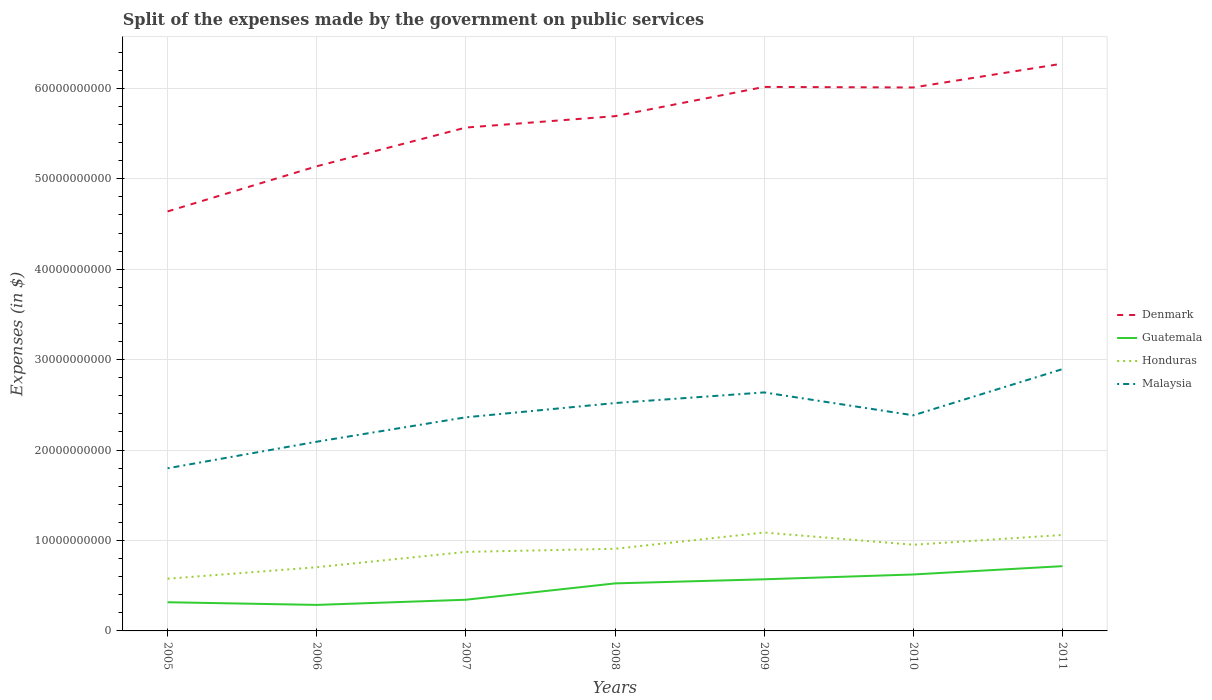How many different coloured lines are there?
Offer a terse response. 4. Is the number of lines equal to the number of legend labels?
Make the answer very short. Yes. Across all years, what is the maximum expenses made by the government on public services in Denmark?
Keep it short and to the point. 4.64e+1. In which year was the expenses made by the government on public services in Guatemala maximum?
Offer a very short reply. 2006. What is the total expenses made by the government on public services in Guatemala in the graph?
Make the answer very short. -3.99e+09. What is the difference between the highest and the second highest expenses made by the government on public services in Malaysia?
Give a very brief answer. 1.10e+1. Is the expenses made by the government on public services in Denmark strictly greater than the expenses made by the government on public services in Malaysia over the years?
Make the answer very short. No. How many lines are there?
Provide a succinct answer. 4. How many years are there in the graph?
Make the answer very short. 7. Where does the legend appear in the graph?
Make the answer very short. Center right. How many legend labels are there?
Your response must be concise. 4. How are the legend labels stacked?
Give a very brief answer. Vertical. What is the title of the graph?
Make the answer very short. Split of the expenses made by the government on public services. What is the label or title of the Y-axis?
Provide a succinct answer. Expenses (in $). What is the Expenses (in $) of Denmark in 2005?
Ensure brevity in your answer.  4.64e+1. What is the Expenses (in $) of Guatemala in 2005?
Keep it short and to the point. 3.17e+09. What is the Expenses (in $) of Honduras in 2005?
Your answer should be compact. 5.77e+09. What is the Expenses (in $) in Malaysia in 2005?
Give a very brief answer. 1.80e+1. What is the Expenses (in $) of Denmark in 2006?
Your answer should be compact. 5.14e+1. What is the Expenses (in $) of Guatemala in 2006?
Provide a short and direct response. 2.88e+09. What is the Expenses (in $) of Honduras in 2006?
Your response must be concise. 7.04e+09. What is the Expenses (in $) in Malaysia in 2006?
Keep it short and to the point. 2.09e+1. What is the Expenses (in $) of Denmark in 2007?
Offer a terse response. 5.57e+1. What is the Expenses (in $) of Guatemala in 2007?
Keep it short and to the point. 3.45e+09. What is the Expenses (in $) in Honduras in 2007?
Offer a very short reply. 8.74e+09. What is the Expenses (in $) in Malaysia in 2007?
Offer a very short reply. 2.36e+1. What is the Expenses (in $) of Denmark in 2008?
Your answer should be compact. 5.69e+1. What is the Expenses (in $) of Guatemala in 2008?
Provide a short and direct response. 5.26e+09. What is the Expenses (in $) in Honduras in 2008?
Give a very brief answer. 9.08e+09. What is the Expenses (in $) of Malaysia in 2008?
Offer a very short reply. 2.52e+1. What is the Expenses (in $) in Denmark in 2009?
Your answer should be compact. 6.02e+1. What is the Expenses (in $) of Guatemala in 2009?
Provide a succinct answer. 5.71e+09. What is the Expenses (in $) of Honduras in 2009?
Offer a terse response. 1.09e+1. What is the Expenses (in $) in Malaysia in 2009?
Your answer should be very brief. 2.64e+1. What is the Expenses (in $) of Denmark in 2010?
Your answer should be compact. 6.01e+1. What is the Expenses (in $) of Guatemala in 2010?
Make the answer very short. 6.24e+09. What is the Expenses (in $) of Honduras in 2010?
Offer a terse response. 9.53e+09. What is the Expenses (in $) in Malaysia in 2010?
Your answer should be compact. 2.38e+1. What is the Expenses (in $) in Denmark in 2011?
Offer a very short reply. 6.27e+1. What is the Expenses (in $) in Guatemala in 2011?
Your answer should be very brief. 7.16e+09. What is the Expenses (in $) of Honduras in 2011?
Your answer should be very brief. 1.06e+1. What is the Expenses (in $) of Malaysia in 2011?
Offer a very short reply. 2.89e+1. Across all years, what is the maximum Expenses (in $) of Denmark?
Keep it short and to the point. 6.27e+1. Across all years, what is the maximum Expenses (in $) in Guatemala?
Your answer should be compact. 7.16e+09. Across all years, what is the maximum Expenses (in $) of Honduras?
Provide a short and direct response. 1.09e+1. Across all years, what is the maximum Expenses (in $) of Malaysia?
Provide a short and direct response. 2.89e+1. Across all years, what is the minimum Expenses (in $) in Denmark?
Keep it short and to the point. 4.64e+1. Across all years, what is the minimum Expenses (in $) of Guatemala?
Your answer should be compact. 2.88e+09. Across all years, what is the minimum Expenses (in $) of Honduras?
Your response must be concise. 5.77e+09. Across all years, what is the minimum Expenses (in $) in Malaysia?
Provide a short and direct response. 1.80e+1. What is the total Expenses (in $) of Denmark in the graph?
Offer a very short reply. 3.93e+11. What is the total Expenses (in $) in Guatemala in the graph?
Offer a terse response. 3.39e+1. What is the total Expenses (in $) in Honduras in the graph?
Make the answer very short. 6.17e+1. What is the total Expenses (in $) in Malaysia in the graph?
Your answer should be compact. 1.67e+11. What is the difference between the Expenses (in $) of Denmark in 2005 and that in 2006?
Offer a terse response. -4.99e+09. What is the difference between the Expenses (in $) in Guatemala in 2005 and that in 2006?
Your answer should be compact. 2.95e+08. What is the difference between the Expenses (in $) in Honduras in 2005 and that in 2006?
Give a very brief answer. -1.27e+09. What is the difference between the Expenses (in $) in Malaysia in 2005 and that in 2006?
Offer a very short reply. -2.94e+09. What is the difference between the Expenses (in $) in Denmark in 2005 and that in 2007?
Your answer should be compact. -9.27e+09. What is the difference between the Expenses (in $) in Guatemala in 2005 and that in 2007?
Your response must be concise. -2.76e+08. What is the difference between the Expenses (in $) of Honduras in 2005 and that in 2007?
Your answer should be very brief. -2.97e+09. What is the difference between the Expenses (in $) of Malaysia in 2005 and that in 2007?
Make the answer very short. -5.64e+09. What is the difference between the Expenses (in $) in Denmark in 2005 and that in 2008?
Make the answer very short. -1.05e+1. What is the difference between the Expenses (in $) of Guatemala in 2005 and that in 2008?
Provide a succinct answer. -2.08e+09. What is the difference between the Expenses (in $) of Honduras in 2005 and that in 2008?
Make the answer very short. -3.31e+09. What is the difference between the Expenses (in $) of Malaysia in 2005 and that in 2008?
Give a very brief answer. -7.21e+09. What is the difference between the Expenses (in $) in Denmark in 2005 and that in 2009?
Keep it short and to the point. -1.38e+1. What is the difference between the Expenses (in $) in Guatemala in 2005 and that in 2009?
Keep it short and to the point. -2.54e+09. What is the difference between the Expenses (in $) of Honduras in 2005 and that in 2009?
Provide a short and direct response. -5.11e+09. What is the difference between the Expenses (in $) of Malaysia in 2005 and that in 2009?
Give a very brief answer. -8.39e+09. What is the difference between the Expenses (in $) in Denmark in 2005 and that in 2010?
Provide a succinct answer. -1.37e+1. What is the difference between the Expenses (in $) of Guatemala in 2005 and that in 2010?
Offer a terse response. -3.07e+09. What is the difference between the Expenses (in $) in Honduras in 2005 and that in 2010?
Your response must be concise. -3.76e+09. What is the difference between the Expenses (in $) in Malaysia in 2005 and that in 2010?
Your answer should be very brief. -5.86e+09. What is the difference between the Expenses (in $) of Denmark in 2005 and that in 2011?
Your answer should be compact. -1.63e+1. What is the difference between the Expenses (in $) of Guatemala in 2005 and that in 2011?
Make the answer very short. -3.99e+09. What is the difference between the Expenses (in $) of Honduras in 2005 and that in 2011?
Make the answer very short. -4.84e+09. What is the difference between the Expenses (in $) in Malaysia in 2005 and that in 2011?
Offer a terse response. -1.10e+1. What is the difference between the Expenses (in $) of Denmark in 2006 and that in 2007?
Your response must be concise. -4.28e+09. What is the difference between the Expenses (in $) in Guatemala in 2006 and that in 2007?
Your answer should be very brief. -5.70e+08. What is the difference between the Expenses (in $) in Honduras in 2006 and that in 2007?
Ensure brevity in your answer.  -1.70e+09. What is the difference between the Expenses (in $) in Malaysia in 2006 and that in 2007?
Your response must be concise. -2.70e+09. What is the difference between the Expenses (in $) in Denmark in 2006 and that in 2008?
Provide a short and direct response. -5.54e+09. What is the difference between the Expenses (in $) of Guatemala in 2006 and that in 2008?
Offer a very short reply. -2.38e+09. What is the difference between the Expenses (in $) in Honduras in 2006 and that in 2008?
Your response must be concise. -2.04e+09. What is the difference between the Expenses (in $) in Malaysia in 2006 and that in 2008?
Your answer should be very brief. -4.27e+09. What is the difference between the Expenses (in $) in Denmark in 2006 and that in 2009?
Your answer should be very brief. -8.77e+09. What is the difference between the Expenses (in $) of Guatemala in 2006 and that in 2009?
Your answer should be very brief. -2.83e+09. What is the difference between the Expenses (in $) in Honduras in 2006 and that in 2009?
Provide a short and direct response. -3.84e+09. What is the difference between the Expenses (in $) of Malaysia in 2006 and that in 2009?
Provide a succinct answer. -5.45e+09. What is the difference between the Expenses (in $) in Denmark in 2006 and that in 2010?
Your answer should be very brief. -8.71e+09. What is the difference between the Expenses (in $) of Guatemala in 2006 and that in 2010?
Provide a succinct answer. -3.36e+09. What is the difference between the Expenses (in $) of Honduras in 2006 and that in 2010?
Your answer should be compact. -2.49e+09. What is the difference between the Expenses (in $) of Malaysia in 2006 and that in 2010?
Your answer should be very brief. -2.92e+09. What is the difference between the Expenses (in $) in Denmark in 2006 and that in 2011?
Your response must be concise. -1.13e+1. What is the difference between the Expenses (in $) of Guatemala in 2006 and that in 2011?
Your answer should be compact. -4.28e+09. What is the difference between the Expenses (in $) in Honduras in 2006 and that in 2011?
Ensure brevity in your answer.  -3.56e+09. What is the difference between the Expenses (in $) of Malaysia in 2006 and that in 2011?
Offer a terse response. -8.03e+09. What is the difference between the Expenses (in $) in Denmark in 2007 and that in 2008?
Your answer should be very brief. -1.26e+09. What is the difference between the Expenses (in $) in Guatemala in 2007 and that in 2008?
Keep it short and to the point. -1.81e+09. What is the difference between the Expenses (in $) of Honduras in 2007 and that in 2008?
Your answer should be compact. -3.42e+08. What is the difference between the Expenses (in $) of Malaysia in 2007 and that in 2008?
Give a very brief answer. -1.57e+09. What is the difference between the Expenses (in $) of Denmark in 2007 and that in 2009?
Your response must be concise. -4.49e+09. What is the difference between the Expenses (in $) in Guatemala in 2007 and that in 2009?
Make the answer very short. -2.26e+09. What is the difference between the Expenses (in $) of Honduras in 2007 and that in 2009?
Offer a very short reply. -2.14e+09. What is the difference between the Expenses (in $) of Malaysia in 2007 and that in 2009?
Ensure brevity in your answer.  -2.75e+09. What is the difference between the Expenses (in $) in Denmark in 2007 and that in 2010?
Offer a terse response. -4.43e+09. What is the difference between the Expenses (in $) in Guatemala in 2007 and that in 2010?
Your answer should be very brief. -2.79e+09. What is the difference between the Expenses (in $) of Honduras in 2007 and that in 2010?
Your answer should be compact. -7.91e+08. What is the difference between the Expenses (in $) of Malaysia in 2007 and that in 2010?
Ensure brevity in your answer.  -2.18e+08. What is the difference between the Expenses (in $) in Denmark in 2007 and that in 2011?
Your response must be concise. -7.07e+09. What is the difference between the Expenses (in $) of Guatemala in 2007 and that in 2011?
Make the answer very short. -3.71e+09. What is the difference between the Expenses (in $) of Honduras in 2007 and that in 2011?
Your answer should be compact. -1.87e+09. What is the difference between the Expenses (in $) in Malaysia in 2007 and that in 2011?
Your response must be concise. -5.33e+09. What is the difference between the Expenses (in $) of Denmark in 2008 and that in 2009?
Keep it short and to the point. -3.23e+09. What is the difference between the Expenses (in $) of Guatemala in 2008 and that in 2009?
Make the answer very short. -4.52e+08. What is the difference between the Expenses (in $) in Honduras in 2008 and that in 2009?
Provide a succinct answer. -1.80e+09. What is the difference between the Expenses (in $) in Malaysia in 2008 and that in 2009?
Give a very brief answer. -1.18e+09. What is the difference between the Expenses (in $) in Denmark in 2008 and that in 2010?
Offer a terse response. -3.17e+09. What is the difference between the Expenses (in $) of Guatemala in 2008 and that in 2010?
Your answer should be very brief. -9.86e+08. What is the difference between the Expenses (in $) in Honduras in 2008 and that in 2010?
Your answer should be very brief. -4.48e+08. What is the difference between the Expenses (in $) of Malaysia in 2008 and that in 2010?
Provide a succinct answer. 1.36e+09. What is the difference between the Expenses (in $) of Denmark in 2008 and that in 2011?
Give a very brief answer. -5.81e+09. What is the difference between the Expenses (in $) of Guatemala in 2008 and that in 2011?
Offer a very short reply. -1.91e+09. What is the difference between the Expenses (in $) of Honduras in 2008 and that in 2011?
Offer a very short reply. -1.53e+09. What is the difference between the Expenses (in $) of Malaysia in 2008 and that in 2011?
Your answer should be compact. -3.75e+09. What is the difference between the Expenses (in $) of Denmark in 2009 and that in 2010?
Ensure brevity in your answer.  6.10e+07. What is the difference between the Expenses (in $) of Guatemala in 2009 and that in 2010?
Ensure brevity in your answer.  -5.34e+08. What is the difference between the Expenses (in $) of Honduras in 2009 and that in 2010?
Your answer should be compact. 1.35e+09. What is the difference between the Expenses (in $) of Malaysia in 2009 and that in 2010?
Your response must be concise. 2.53e+09. What is the difference between the Expenses (in $) of Denmark in 2009 and that in 2011?
Give a very brief answer. -2.58e+09. What is the difference between the Expenses (in $) in Guatemala in 2009 and that in 2011?
Keep it short and to the point. -1.45e+09. What is the difference between the Expenses (in $) of Honduras in 2009 and that in 2011?
Ensure brevity in your answer.  2.73e+08. What is the difference between the Expenses (in $) of Malaysia in 2009 and that in 2011?
Your answer should be very brief. -2.58e+09. What is the difference between the Expenses (in $) in Denmark in 2010 and that in 2011?
Offer a terse response. -2.64e+09. What is the difference between the Expenses (in $) of Guatemala in 2010 and that in 2011?
Your answer should be very brief. -9.19e+08. What is the difference between the Expenses (in $) in Honduras in 2010 and that in 2011?
Your answer should be very brief. -1.08e+09. What is the difference between the Expenses (in $) in Malaysia in 2010 and that in 2011?
Keep it short and to the point. -5.11e+09. What is the difference between the Expenses (in $) of Denmark in 2005 and the Expenses (in $) of Guatemala in 2006?
Give a very brief answer. 4.35e+1. What is the difference between the Expenses (in $) of Denmark in 2005 and the Expenses (in $) of Honduras in 2006?
Provide a short and direct response. 3.93e+1. What is the difference between the Expenses (in $) of Denmark in 2005 and the Expenses (in $) of Malaysia in 2006?
Your answer should be compact. 2.55e+1. What is the difference between the Expenses (in $) of Guatemala in 2005 and the Expenses (in $) of Honduras in 2006?
Provide a short and direct response. -3.87e+09. What is the difference between the Expenses (in $) in Guatemala in 2005 and the Expenses (in $) in Malaysia in 2006?
Your response must be concise. -1.78e+1. What is the difference between the Expenses (in $) in Honduras in 2005 and the Expenses (in $) in Malaysia in 2006?
Provide a short and direct response. -1.52e+1. What is the difference between the Expenses (in $) of Denmark in 2005 and the Expenses (in $) of Guatemala in 2007?
Make the answer very short. 4.29e+1. What is the difference between the Expenses (in $) in Denmark in 2005 and the Expenses (in $) in Honduras in 2007?
Provide a short and direct response. 3.76e+1. What is the difference between the Expenses (in $) in Denmark in 2005 and the Expenses (in $) in Malaysia in 2007?
Offer a very short reply. 2.28e+1. What is the difference between the Expenses (in $) of Guatemala in 2005 and the Expenses (in $) of Honduras in 2007?
Provide a short and direct response. -5.57e+09. What is the difference between the Expenses (in $) in Guatemala in 2005 and the Expenses (in $) in Malaysia in 2007?
Give a very brief answer. -2.05e+1. What is the difference between the Expenses (in $) in Honduras in 2005 and the Expenses (in $) in Malaysia in 2007?
Your answer should be very brief. -1.79e+1. What is the difference between the Expenses (in $) of Denmark in 2005 and the Expenses (in $) of Guatemala in 2008?
Give a very brief answer. 4.11e+1. What is the difference between the Expenses (in $) in Denmark in 2005 and the Expenses (in $) in Honduras in 2008?
Offer a terse response. 3.73e+1. What is the difference between the Expenses (in $) in Denmark in 2005 and the Expenses (in $) in Malaysia in 2008?
Your answer should be compact. 2.12e+1. What is the difference between the Expenses (in $) in Guatemala in 2005 and the Expenses (in $) in Honduras in 2008?
Your response must be concise. -5.91e+09. What is the difference between the Expenses (in $) in Guatemala in 2005 and the Expenses (in $) in Malaysia in 2008?
Offer a terse response. -2.20e+1. What is the difference between the Expenses (in $) of Honduras in 2005 and the Expenses (in $) of Malaysia in 2008?
Give a very brief answer. -1.94e+1. What is the difference between the Expenses (in $) of Denmark in 2005 and the Expenses (in $) of Guatemala in 2009?
Give a very brief answer. 4.07e+1. What is the difference between the Expenses (in $) of Denmark in 2005 and the Expenses (in $) of Honduras in 2009?
Offer a terse response. 3.55e+1. What is the difference between the Expenses (in $) in Denmark in 2005 and the Expenses (in $) in Malaysia in 2009?
Your response must be concise. 2.00e+1. What is the difference between the Expenses (in $) in Guatemala in 2005 and the Expenses (in $) in Honduras in 2009?
Offer a very short reply. -7.71e+09. What is the difference between the Expenses (in $) in Guatemala in 2005 and the Expenses (in $) in Malaysia in 2009?
Keep it short and to the point. -2.32e+1. What is the difference between the Expenses (in $) of Honduras in 2005 and the Expenses (in $) of Malaysia in 2009?
Offer a very short reply. -2.06e+1. What is the difference between the Expenses (in $) in Denmark in 2005 and the Expenses (in $) in Guatemala in 2010?
Give a very brief answer. 4.01e+1. What is the difference between the Expenses (in $) in Denmark in 2005 and the Expenses (in $) in Honduras in 2010?
Provide a short and direct response. 3.69e+1. What is the difference between the Expenses (in $) of Denmark in 2005 and the Expenses (in $) of Malaysia in 2010?
Offer a very short reply. 2.25e+1. What is the difference between the Expenses (in $) in Guatemala in 2005 and the Expenses (in $) in Honduras in 2010?
Keep it short and to the point. -6.36e+09. What is the difference between the Expenses (in $) of Guatemala in 2005 and the Expenses (in $) of Malaysia in 2010?
Make the answer very short. -2.07e+1. What is the difference between the Expenses (in $) in Honduras in 2005 and the Expenses (in $) in Malaysia in 2010?
Keep it short and to the point. -1.81e+1. What is the difference between the Expenses (in $) of Denmark in 2005 and the Expenses (in $) of Guatemala in 2011?
Offer a very short reply. 3.92e+1. What is the difference between the Expenses (in $) of Denmark in 2005 and the Expenses (in $) of Honduras in 2011?
Offer a terse response. 3.58e+1. What is the difference between the Expenses (in $) in Denmark in 2005 and the Expenses (in $) in Malaysia in 2011?
Make the answer very short. 1.74e+1. What is the difference between the Expenses (in $) in Guatemala in 2005 and the Expenses (in $) in Honduras in 2011?
Ensure brevity in your answer.  -7.44e+09. What is the difference between the Expenses (in $) of Guatemala in 2005 and the Expenses (in $) of Malaysia in 2011?
Your answer should be compact. -2.58e+1. What is the difference between the Expenses (in $) of Honduras in 2005 and the Expenses (in $) of Malaysia in 2011?
Your answer should be very brief. -2.32e+1. What is the difference between the Expenses (in $) in Denmark in 2006 and the Expenses (in $) in Guatemala in 2007?
Keep it short and to the point. 4.79e+1. What is the difference between the Expenses (in $) of Denmark in 2006 and the Expenses (in $) of Honduras in 2007?
Give a very brief answer. 4.26e+1. What is the difference between the Expenses (in $) in Denmark in 2006 and the Expenses (in $) in Malaysia in 2007?
Offer a terse response. 2.78e+1. What is the difference between the Expenses (in $) in Guatemala in 2006 and the Expenses (in $) in Honduras in 2007?
Make the answer very short. -5.86e+09. What is the difference between the Expenses (in $) in Guatemala in 2006 and the Expenses (in $) in Malaysia in 2007?
Provide a short and direct response. -2.07e+1. What is the difference between the Expenses (in $) in Honduras in 2006 and the Expenses (in $) in Malaysia in 2007?
Offer a terse response. -1.66e+1. What is the difference between the Expenses (in $) in Denmark in 2006 and the Expenses (in $) in Guatemala in 2008?
Your answer should be very brief. 4.61e+1. What is the difference between the Expenses (in $) of Denmark in 2006 and the Expenses (in $) of Honduras in 2008?
Your answer should be compact. 4.23e+1. What is the difference between the Expenses (in $) in Denmark in 2006 and the Expenses (in $) in Malaysia in 2008?
Provide a succinct answer. 2.62e+1. What is the difference between the Expenses (in $) in Guatemala in 2006 and the Expenses (in $) in Honduras in 2008?
Provide a short and direct response. -6.20e+09. What is the difference between the Expenses (in $) of Guatemala in 2006 and the Expenses (in $) of Malaysia in 2008?
Provide a succinct answer. -2.23e+1. What is the difference between the Expenses (in $) in Honduras in 2006 and the Expenses (in $) in Malaysia in 2008?
Provide a short and direct response. -1.82e+1. What is the difference between the Expenses (in $) in Denmark in 2006 and the Expenses (in $) in Guatemala in 2009?
Offer a terse response. 4.57e+1. What is the difference between the Expenses (in $) in Denmark in 2006 and the Expenses (in $) in Honduras in 2009?
Keep it short and to the point. 4.05e+1. What is the difference between the Expenses (in $) of Denmark in 2006 and the Expenses (in $) of Malaysia in 2009?
Your answer should be very brief. 2.50e+1. What is the difference between the Expenses (in $) in Guatemala in 2006 and the Expenses (in $) in Honduras in 2009?
Your answer should be very brief. -8.00e+09. What is the difference between the Expenses (in $) of Guatemala in 2006 and the Expenses (in $) of Malaysia in 2009?
Make the answer very short. -2.35e+1. What is the difference between the Expenses (in $) in Honduras in 2006 and the Expenses (in $) in Malaysia in 2009?
Make the answer very short. -1.93e+1. What is the difference between the Expenses (in $) of Denmark in 2006 and the Expenses (in $) of Guatemala in 2010?
Your answer should be very brief. 4.51e+1. What is the difference between the Expenses (in $) in Denmark in 2006 and the Expenses (in $) in Honduras in 2010?
Keep it short and to the point. 4.19e+1. What is the difference between the Expenses (in $) of Denmark in 2006 and the Expenses (in $) of Malaysia in 2010?
Keep it short and to the point. 2.75e+1. What is the difference between the Expenses (in $) of Guatemala in 2006 and the Expenses (in $) of Honduras in 2010?
Offer a terse response. -6.65e+09. What is the difference between the Expenses (in $) of Guatemala in 2006 and the Expenses (in $) of Malaysia in 2010?
Your answer should be very brief. -2.10e+1. What is the difference between the Expenses (in $) in Honduras in 2006 and the Expenses (in $) in Malaysia in 2010?
Offer a terse response. -1.68e+1. What is the difference between the Expenses (in $) in Denmark in 2006 and the Expenses (in $) in Guatemala in 2011?
Offer a terse response. 4.42e+1. What is the difference between the Expenses (in $) in Denmark in 2006 and the Expenses (in $) in Honduras in 2011?
Provide a succinct answer. 4.08e+1. What is the difference between the Expenses (in $) of Denmark in 2006 and the Expenses (in $) of Malaysia in 2011?
Give a very brief answer. 2.24e+1. What is the difference between the Expenses (in $) of Guatemala in 2006 and the Expenses (in $) of Honduras in 2011?
Make the answer very short. -7.73e+09. What is the difference between the Expenses (in $) of Guatemala in 2006 and the Expenses (in $) of Malaysia in 2011?
Provide a short and direct response. -2.61e+1. What is the difference between the Expenses (in $) of Honduras in 2006 and the Expenses (in $) of Malaysia in 2011?
Offer a terse response. -2.19e+1. What is the difference between the Expenses (in $) in Denmark in 2007 and the Expenses (in $) in Guatemala in 2008?
Your answer should be very brief. 5.04e+1. What is the difference between the Expenses (in $) of Denmark in 2007 and the Expenses (in $) of Honduras in 2008?
Make the answer very short. 4.66e+1. What is the difference between the Expenses (in $) of Denmark in 2007 and the Expenses (in $) of Malaysia in 2008?
Ensure brevity in your answer.  3.05e+1. What is the difference between the Expenses (in $) of Guatemala in 2007 and the Expenses (in $) of Honduras in 2008?
Provide a short and direct response. -5.63e+09. What is the difference between the Expenses (in $) of Guatemala in 2007 and the Expenses (in $) of Malaysia in 2008?
Keep it short and to the point. -2.17e+1. What is the difference between the Expenses (in $) in Honduras in 2007 and the Expenses (in $) in Malaysia in 2008?
Your answer should be compact. -1.65e+1. What is the difference between the Expenses (in $) of Denmark in 2007 and the Expenses (in $) of Guatemala in 2009?
Your response must be concise. 5.00e+1. What is the difference between the Expenses (in $) of Denmark in 2007 and the Expenses (in $) of Honduras in 2009?
Offer a terse response. 4.48e+1. What is the difference between the Expenses (in $) of Denmark in 2007 and the Expenses (in $) of Malaysia in 2009?
Your answer should be compact. 2.93e+1. What is the difference between the Expenses (in $) of Guatemala in 2007 and the Expenses (in $) of Honduras in 2009?
Provide a succinct answer. -7.43e+09. What is the difference between the Expenses (in $) of Guatemala in 2007 and the Expenses (in $) of Malaysia in 2009?
Offer a terse response. -2.29e+1. What is the difference between the Expenses (in $) of Honduras in 2007 and the Expenses (in $) of Malaysia in 2009?
Provide a succinct answer. -1.76e+1. What is the difference between the Expenses (in $) of Denmark in 2007 and the Expenses (in $) of Guatemala in 2010?
Make the answer very short. 4.94e+1. What is the difference between the Expenses (in $) in Denmark in 2007 and the Expenses (in $) in Honduras in 2010?
Make the answer very short. 4.61e+1. What is the difference between the Expenses (in $) in Denmark in 2007 and the Expenses (in $) in Malaysia in 2010?
Your answer should be very brief. 3.18e+1. What is the difference between the Expenses (in $) in Guatemala in 2007 and the Expenses (in $) in Honduras in 2010?
Provide a succinct answer. -6.08e+09. What is the difference between the Expenses (in $) in Guatemala in 2007 and the Expenses (in $) in Malaysia in 2010?
Your answer should be compact. -2.04e+1. What is the difference between the Expenses (in $) in Honduras in 2007 and the Expenses (in $) in Malaysia in 2010?
Your response must be concise. -1.51e+1. What is the difference between the Expenses (in $) in Denmark in 2007 and the Expenses (in $) in Guatemala in 2011?
Your answer should be compact. 4.85e+1. What is the difference between the Expenses (in $) of Denmark in 2007 and the Expenses (in $) of Honduras in 2011?
Offer a very short reply. 4.51e+1. What is the difference between the Expenses (in $) in Denmark in 2007 and the Expenses (in $) in Malaysia in 2011?
Offer a terse response. 2.67e+1. What is the difference between the Expenses (in $) of Guatemala in 2007 and the Expenses (in $) of Honduras in 2011?
Offer a very short reply. -7.16e+09. What is the difference between the Expenses (in $) of Guatemala in 2007 and the Expenses (in $) of Malaysia in 2011?
Offer a terse response. -2.55e+1. What is the difference between the Expenses (in $) of Honduras in 2007 and the Expenses (in $) of Malaysia in 2011?
Keep it short and to the point. -2.02e+1. What is the difference between the Expenses (in $) of Denmark in 2008 and the Expenses (in $) of Guatemala in 2009?
Provide a short and direct response. 5.12e+1. What is the difference between the Expenses (in $) of Denmark in 2008 and the Expenses (in $) of Honduras in 2009?
Your answer should be compact. 4.60e+1. What is the difference between the Expenses (in $) of Denmark in 2008 and the Expenses (in $) of Malaysia in 2009?
Provide a succinct answer. 3.05e+1. What is the difference between the Expenses (in $) of Guatemala in 2008 and the Expenses (in $) of Honduras in 2009?
Your response must be concise. -5.63e+09. What is the difference between the Expenses (in $) in Guatemala in 2008 and the Expenses (in $) in Malaysia in 2009?
Provide a succinct answer. -2.11e+1. What is the difference between the Expenses (in $) in Honduras in 2008 and the Expenses (in $) in Malaysia in 2009?
Offer a very short reply. -1.73e+1. What is the difference between the Expenses (in $) of Denmark in 2008 and the Expenses (in $) of Guatemala in 2010?
Provide a succinct answer. 5.07e+1. What is the difference between the Expenses (in $) of Denmark in 2008 and the Expenses (in $) of Honduras in 2010?
Keep it short and to the point. 4.74e+1. What is the difference between the Expenses (in $) in Denmark in 2008 and the Expenses (in $) in Malaysia in 2010?
Give a very brief answer. 3.31e+1. What is the difference between the Expenses (in $) of Guatemala in 2008 and the Expenses (in $) of Honduras in 2010?
Give a very brief answer. -4.27e+09. What is the difference between the Expenses (in $) in Guatemala in 2008 and the Expenses (in $) in Malaysia in 2010?
Your answer should be very brief. -1.86e+1. What is the difference between the Expenses (in $) of Honduras in 2008 and the Expenses (in $) of Malaysia in 2010?
Your answer should be compact. -1.48e+1. What is the difference between the Expenses (in $) in Denmark in 2008 and the Expenses (in $) in Guatemala in 2011?
Make the answer very short. 4.98e+1. What is the difference between the Expenses (in $) in Denmark in 2008 and the Expenses (in $) in Honduras in 2011?
Provide a succinct answer. 4.63e+1. What is the difference between the Expenses (in $) of Denmark in 2008 and the Expenses (in $) of Malaysia in 2011?
Offer a very short reply. 2.80e+1. What is the difference between the Expenses (in $) of Guatemala in 2008 and the Expenses (in $) of Honduras in 2011?
Offer a very short reply. -5.35e+09. What is the difference between the Expenses (in $) in Guatemala in 2008 and the Expenses (in $) in Malaysia in 2011?
Offer a very short reply. -2.37e+1. What is the difference between the Expenses (in $) of Honduras in 2008 and the Expenses (in $) of Malaysia in 2011?
Offer a terse response. -1.99e+1. What is the difference between the Expenses (in $) of Denmark in 2009 and the Expenses (in $) of Guatemala in 2010?
Provide a short and direct response. 5.39e+1. What is the difference between the Expenses (in $) in Denmark in 2009 and the Expenses (in $) in Honduras in 2010?
Provide a short and direct response. 5.06e+1. What is the difference between the Expenses (in $) in Denmark in 2009 and the Expenses (in $) in Malaysia in 2010?
Your answer should be very brief. 3.63e+1. What is the difference between the Expenses (in $) of Guatemala in 2009 and the Expenses (in $) of Honduras in 2010?
Provide a succinct answer. -3.82e+09. What is the difference between the Expenses (in $) of Guatemala in 2009 and the Expenses (in $) of Malaysia in 2010?
Your answer should be very brief. -1.81e+1. What is the difference between the Expenses (in $) in Honduras in 2009 and the Expenses (in $) in Malaysia in 2010?
Give a very brief answer. -1.30e+1. What is the difference between the Expenses (in $) of Denmark in 2009 and the Expenses (in $) of Guatemala in 2011?
Your response must be concise. 5.30e+1. What is the difference between the Expenses (in $) in Denmark in 2009 and the Expenses (in $) in Honduras in 2011?
Provide a succinct answer. 4.95e+1. What is the difference between the Expenses (in $) in Denmark in 2009 and the Expenses (in $) in Malaysia in 2011?
Keep it short and to the point. 3.12e+1. What is the difference between the Expenses (in $) in Guatemala in 2009 and the Expenses (in $) in Honduras in 2011?
Give a very brief answer. -4.90e+09. What is the difference between the Expenses (in $) of Guatemala in 2009 and the Expenses (in $) of Malaysia in 2011?
Offer a terse response. -2.32e+1. What is the difference between the Expenses (in $) in Honduras in 2009 and the Expenses (in $) in Malaysia in 2011?
Ensure brevity in your answer.  -1.81e+1. What is the difference between the Expenses (in $) in Denmark in 2010 and the Expenses (in $) in Guatemala in 2011?
Keep it short and to the point. 5.29e+1. What is the difference between the Expenses (in $) in Denmark in 2010 and the Expenses (in $) in Honduras in 2011?
Your answer should be compact. 4.95e+1. What is the difference between the Expenses (in $) in Denmark in 2010 and the Expenses (in $) in Malaysia in 2011?
Your answer should be very brief. 3.11e+1. What is the difference between the Expenses (in $) in Guatemala in 2010 and the Expenses (in $) in Honduras in 2011?
Your response must be concise. -4.37e+09. What is the difference between the Expenses (in $) in Guatemala in 2010 and the Expenses (in $) in Malaysia in 2011?
Keep it short and to the point. -2.27e+1. What is the difference between the Expenses (in $) in Honduras in 2010 and the Expenses (in $) in Malaysia in 2011?
Give a very brief answer. -1.94e+1. What is the average Expenses (in $) in Denmark per year?
Your answer should be compact. 5.62e+1. What is the average Expenses (in $) in Guatemala per year?
Offer a very short reply. 4.84e+09. What is the average Expenses (in $) of Honduras per year?
Provide a succinct answer. 8.81e+09. What is the average Expenses (in $) in Malaysia per year?
Your answer should be compact. 2.38e+1. In the year 2005, what is the difference between the Expenses (in $) of Denmark and Expenses (in $) of Guatemala?
Ensure brevity in your answer.  4.32e+1. In the year 2005, what is the difference between the Expenses (in $) in Denmark and Expenses (in $) in Honduras?
Make the answer very short. 4.06e+1. In the year 2005, what is the difference between the Expenses (in $) of Denmark and Expenses (in $) of Malaysia?
Your answer should be compact. 2.84e+1. In the year 2005, what is the difference between the Expenses (in $) of Guatemala and Expenses (in $) of Honduras?
Offer a terse response. -2.60e+09. In the year 2005, what is the difference between the Expenses (in $) of Guatemala and Expenses (in $) of Malaysia?
Keep it short and to the point. -1.48e+1. In the year 2005, what is the difference between the Expenses (in $) of Honduras and Expenses (in $) of Malaysia?
Keep it short and to the point. -1.22e+1. In the year 2006, what is the difference between the Expenses (in $) in Denmark and Expenses (in $) in Guatemala?
Your answer should be very brief. 4.85e+1. In the year 2006, what is the difference between the Expenses (in $) in Denmark and Expenses (in $) in Honduras?
Your answer should be compact. 4.43e+1. In the year 2006, what is the difference between the Expenses (in $) in Denmark and Expenses (in $) in Malaysia?
Ensure brevity in your answer.  3.05e+1. In the year 2006, what is the difference between the Expenses (in $) of Guatemala and Expenses (in $) of Honduras?
Offer a very short reply. -4.17e+09. In the year 2006, what is the difference between the Expenses (in $) in Guatemala and Expenses (in $) in Malaysia?
Provide a short and direct response. -1.80e+1. In the year 2006, what is the difference between the Expenses (in $) in Honduras and Expenses (in $) in Malaysia?
Give a very brief answer. -1.39e+1. In the year 2007, what is the difference between the Expenses (in $) of Denmark and Expenses (in $) of Guatemala?
Provide a short and direct response. 5.22e+1. In the year 2007, what is the difference between the Expenses (in $) of Denmark and Expenses (in $) of Honduras?
Provide a succinct answer. 4.69e+1. In the year 2007, what is the difference between the Expenses (in $) in Denmark and Expenses (in $) in Malaysia?
Your answer should be very brief. 3.20e+1. In the year 2007, what is the difference between the Expenses (in $) of Guatemala and Expenses (in $) of Honduras?
Offer a very short reply. -5.29e+09. In the year 2007, what is the difference between the Expenses (in $) in Guatemala and Expenses (in $) in Malaysia?
Offer a very short reply. -2.02e+1. In the year 2007, what is the difference between the Expenses (in $) in Honduras and Expenses (in $) in Malaysia?
Your answer should be very brief. -1.49e+1. In the year 2008, what is the difference between the Expenses (in $) of Denmark and Expenses (in $) of Guatemala?
Your answer should be compact. 5.17e+1. In the year 2008, what is the difference between the Expenses (in $) in Denmark and Expenses (in $) in Honduras?
Ensure brevity in your answer.  4.78e+1. In the year 2008, what is the difference between the Expenses (in $) of Denmark and Expenses (in $) of Malaysia?
Provide a succinct answer. 3.17e+1. In the year 2008, what is the difference between the Expenses (in $) in Guatemala and Expenses (in $) in Honduras?
Your answer should be compact. -3.83e+09. In the year 2008, what is the difference between the Expenses (in $) in Guatemala and Expenses (in $) in Malaysia?
Provide a succinct answer. -1.99e+1. In the year 2008, what is the difference between the Expenses (in $) of Honduras and Expenses (in $) of Malaysia?
Give a very brief answer. -1.61e+1. In the year 2009, what is the difference between the Expenses (in $) of Denmark and Expenses (in $) of Guatemala?
Ensure brevity in your answer.  5.44e+1. In the year 2009, what is the difference between the Expenses (in $) in Denmark and Expenses (in $) in Honduras?
Your answer should be very brief. 4.93e+1. In the year 2009, what is the difference between the Expenses (in $) of Denmark and Expenses (in $) of Malaysia?
Keep it short and to the point. 3.38e+1. In the year 2009, what is the difference between the Expenses (in $) of Guatemala and Expenses (in $) of Honduras?
Offer a very short reply. -5.17e+09. In the year 2009, what is the difference between the Expenses (in $) of Guatemala and Expenses (in $) of Malaysia?
Your response must be concise. -2.07e+1. In the year 2009, what is the difference between the Expenses (in $) in Honduras and Expenses (in $) in Malaysia?
Make the answer very short. -1.55e+1. In the year 2010, what is the difference between the Expenses (in $) in Denmark and Expenses (in $) in Guatemala?
Provide a short and direct response. 5.39e+1. In the year 2010, what is the difference between the Expenses (in $) in Denmark and Expenses (in $) in Honduras?
Provide a succinct answer. 5.06e+1. In the year 2010, what is the difference between the Expenses (in $) of Denmark and Expenses (in $) of Malaysia?
Offer a terse response. 3.63e+1. In the year 2010, what is the difference between the Expenses (in $) in Guatemala and Expenses (in $) in Honduras?
Your answer should be very brief. -3.29e+09. In the year 2010, what is the difference between the Expenses (in $) of Guatemala and Expenses (in $) of Malaysia?
Provide a short and direct response. -1.76e+1. In the year 2010, what is the difference between the Expenses (in $) in Honduras and Expenses (in $) in Malaysia?
Give a very brief answer. -1.43e+1. In the year 2011, what is the difference between the Expenses (in $) of Denmark and Expenses (in $) of Guatemala?
Provide a short and direct response. 5.56e+1. In the year 2011, what is the difference between the Expenses (in $) in Denmark and Expenses (in $) in Honduras?
Make the answer very short. 5.21e+1. In the year 2011, what is the difference between the Expenses (in $) in Denmark and Expenses (in $) in Malaysia?
Provide a short and direct response. 3.38e+1. In the year 2011, what is the difference between the Expenses (in $) of Guatemala and Expenses (in $) of Honduras?
Provide a succinct answer. -3.45e+09. In the year 2011, what is the difference between the Expenses (in $) of Guatemala and Expenses (in $) of Malaysia?
Your answer should be very brief. -2.18e+1. In the year 2011, what is the difference between the Expenses (in $) in Honduras and Expenses (in $) in Malaysia?
Give a very brief answer. -1.83e+1. What is the ratio of the Expenses (in $) of Denmark in 2005 to that in 2006?
Ensure brevity in your answer.  0.9. What is the ratio of the Expenses (in $) of Guatemala in 2005 to that in 2006?
Ensure brevity in your answer.  1.1. What is the ratio of the Expenses (in $) of Honduras in 2005 to that in 2006?
Your answer should be very brief. 0.82. What is the ratio of the Expenses (in $) in Malaysia in 2005 to that in 2006?
Your response must be concise. 0.86. What is the ratio of the Expenses (in $) in Denmark in 2005 to that in 2007?
Your answer should be very brief. 0.83. What is the ratio of the Expenses (in $) of Honduras in 2005 to that in 2007?
Offer a very short reply. 0.66. What is the ratio of the Expenses (in $) in Malaysia in 2005 to that in 2007?
Make the answer very short. 0.76. What is the ratio of the Expenses (in $) in Denmark in 2005 to that in 2008?
Make the answer very short. 0.81. What is the ratio of the Expenses (in $) in Guatemala in 2005 to that in 2008?
Your response must be concise. 0.6. What is the ratio of the Expenses (in $) of Honduras in 2005 to that in 2008?
Keep it short and to the point. 0.64. What is the ratio of the Expenses (in $) in Malaysia in 2005 to that in 2008?
Your answer should be very brief. 0.71. What is the ratio of the Expenses (in $) of Denmark in 2005 to that in 2009?
Your answer should be very brief. 0.77. What is the ratio of the Expenses (in $) in Guatemala in 2005 to that in 2009?
Provide a short and direct response. 0.56. What is the ratio of the Expenses (in $) of Honduras in 2005 to that in 2009?
Provide a succinct answer. 0.53. What is the ratio of the Expenses (in $) in Malaysia in 2005 to that in 2009?
Your response must be concise. 0.68. What is the ratio of the Expenses (in $) of Denmark in 2005 to that in 2010?
Your answer should be very brief. 0.77. What is the ratio of the Expenses (in $) of Guatemala in 2005 to that in 2010?
Offer a terse response. 0.51. What is the ratio of the Expenses (in $) in Honduras in 2005 to that in 2010?
Your answer should be very brief. 0.61. What is the ratio of the Expenses (in $) of Malaysia in 2005 to that in 2010?
Offer a terse response. 0.75. What is the ratio of the Expenses (in $) in Denmark in 2005 to that in 2011?
Offer a terse response. 0.74. What is the ratio of the Expenses (in $) of Guatemala in 2005 to that in 2011?
Give a very brief answer. 0.44. What is the ratio of the Expenses (in $) in Honduras in 2005 to that in 2011?
Offer a very short reply. 0.54. What is the ratio of the Expenses (in $) in Malaysia in 2005 to that in 2011?
Provide a succinct answer. 0.62. What is the ratio of the Expenses (in $) in Guatemala in 2006 to that in 2007?
Provide a short and direct response. 0.83. What is the ratio of the Expenses (in $) in Honduras in 2006 to that in 2007?
Offer a very short reply. 0.81. What is the ratio of the Expenses (in $) of Malaysia in 2006 to that in 2007?
Offer a very short reply. 0.89. What is the ratio of the Expenses (in $) of Denmark in 2006 to that in 2008?
Keep it short and to the point. 0.9. What is the ratio of the Expenses (in $) in Guatemala in 2006 to that in 2008?
Your answer should be very brief. 0.55. What is the ratio of the Expenses (in $) of Honduras in 2006 to that in 2008?
Ensure brevity in your answer.  0.78. What is the ratio of the Expenses (in $) of Malaysia in 2006 to that in 2008?
Offer a terse response. 0.83. What is the ratio of the Expenses (in $) of Denmark in 2006 to that in 2009?
Your response must be concise. 0.85. What is the ratio of the Expenses (in $) in Guatemala in 2006 to that in 2009?
Make the answer very short. 0.5. What is the ratio of the Expenses (in $) in Honduras in 2006 to that in 2009?
Your answer should be very brief. 0.65. What is the ratio of the Expenses (in $) of Malaysia in 2006 to that in 2009?
Make the answer very short. 0.79. What is the ratio of the Expenses (in $) in Denmark in 2006 to that in 2010?
Ensure brevity in your answer.  0.85. What is the ratio of the Expenses (in $) of Guatemala in 2006 to that in 2010?
Offer a terse response. 0.46. What is the ratio of the Expenses (in $) in Honduras in 2006 to that in 2010?
Provide a short and direct response. 0.74. What is the ratio of the Expenses (in $) in Malaysia in 2006 to that in 2010?
Make the answer very short. 0.88. What is the ratio of the Expenses (in $) of Denmark in 2006 to that in 2011?
Your answer should be very brief. 0.82. What is the ratio of the Expenses (in $) of Guatemala in 2006 to that in 2011?
Ensure brevity in your answer.  0.4. What is the ratio of the Expenses (in $) of Honduras in 2006 to that in 2011?
Your answer should be very brief. 0.66. What is the ratio of the Expenses (in $) in Malaysia in 2006 to that in 2011?
Your answer should be very brief. 0.72. What is the ratio of the Expenses (in $) of Denmark in 2007 to that in 2008?
Provide a short and direct response. 0.98. What is the ratio of the Expenses (in $) in Guatemala in 2007 to that in 2008?
Offer a very short reply. 0.66. What is the ratio of the Expenses (in $) in Honduras in 2007 to that in 2008?
Your response must be concise. 0.96. What is the ratio of the Expenses (in $) of Denmark in 2007 to that in 2009?
Provide a short and direct response. 0.93. What is the ratio of the Expenses (in $) of Guatemala in 2007 to that in 2009?
Your response must be concise. 0.6. What is the ratio of the Expenses (in $) in Honduras in 2007 to that in 2009?
Your answer should be compact. 0.8. What is the ratio of the Expenses (in $) of Malaysia in 2007 to that in 2009?
Your answer should be compact. 0.9. What is the ratio of the Expenses (in $) of Denmark in 2007 to that in 2010?
Provide a short and direct response. 0.93. What is the ratio of the Expenses (in $) in Guatemala in 2007 to that in 2010?
Provide a succinct answer. 0.55. What is the ratio of the Expenses (in $) in Honduras in 2007 to that in 2010?
Your answer should be very brief. 0.92. What is the ratio of the Expenses (in $) in Malaysia in 2007 to that in 2010?
Provide a short and direct response. 0.99. What is the ratio of the Expenses (in $) of Denmark in 2007 to that in 2011?
Provide a succinct answer. 0.89. What is the ratio of the Expenses (in $) of Guatemala in 2007 to that in 2011?
Your response must be concise. 0.48. What is the ratio of the Expenses (in $) of Honduras in 2007 to that in 2011?
Provide a short and direct response. 0.82. What is the ratio of the Expenses (in $) in Malaysia in 2007 to that in 2011?
Make the answer very short. 0.82. What is the ratio of the Expenses (in $) in Denmark in 2008 to that in 2009?
Ensure brevity in your answer.  0.95. What is the ratio of the Expenses (in $) in Guatemala in 2008 to that in 2009?
Your response must be concise. 0.92. What is the ratio of the Expenses (in $) of Honduras in 2008 to that in 2009?
Your response must be concise. 0.83. What is the ratio of the Expenses (in $) in Malaysia in 2008 to that in 2009?
Keep it short and to the point. 0.96. What is the ratio of the Expenses (in $) in Denmark in 2008 to that in 2010?
Offer a very short reply. 0.95. What is the ratio of the Expenses (in $) of Guatemala in 2008 to that in 2010?
Give a very brief answer. 0.84. What is the ratio of the Expenses (in $) in Honduras in 2008 to that in 2010?
Offer a very short reply. 0.95. What is the ratio of the Expenses (in $) in Malaysia in 2008 to that in 2010?
Give a very brief answer. 1.06. What is the ratio of the Expenses (in $) in Denmark in 2008 to that in 2011?
Offer a very short reply. 0.91. What is the ratio of the Expenses (in $) of Guatemala in 2008 to that in 2011?
Make the answer very short. 0.73. What is the ratio of the Expenses (in $) in Honduras in 2008 to that in 2011?
Ensure brevity in your answer.  0.86. What is the ratio of the Expenses (in $) of Malaysia in 2008 to that in 2011?
Offer a terse response. 0.87. What is the ratio of the Expenses (in $) in Guatemala in 2009 to that in 2010?
Make the answer very short. 0.91. What is the ratio of the Expenses (in $) in Honduras in 2009 to that in 2010?
Make the answer very short. 1.14. What is the ratio of the Expenses (in $) in Malaysia in 2009 to that in 2010?
Give a very brief answer. 1.11. What is the ratio of the Expenses (in $) in Guatemala in 2009 to that in 2011?
Your response must be concise. 0.8. What is the ratio of the Expenses (in $) of Honduras in 2009 to that in 2011?
Give a very brief answer. 1.03. What is the ratio of the Expenses (in $) of Malaysia in 2009 to that in 2011?
Your answer should be compact. 0.91. What is the ratio of the Expenses (in $) of Denmark in 2010 to that in 2011?
Your answer should be compact. 0.96. What is the ratio of the Expenses (in $) in Guatemala in 2010 to that in 2011?
Provide a short and direct response. 0.87. What is the ratio of the Expenses (in $) of Honduras in 2010 to that in 2011?
Provide a short and direct response. 0.9. What is the ratio of the Expenses (in $) in Malaysia in 2010 to that in 2011?
Provide a short and direct response. 0.82. What is the difference between the highest and the second highest Expenses (in $) in Denmark?
Your response must be concise. 2.58e+09. What is the difference between the highest and the second highest Expenses (in $) of Guatemala?
Keep it short and to the point. 9.19e+08. What is the difference between the highest and the second highest Expenses (in $) in Honduras?
Provide a short and direct response. 2.73e+08. What is the difference between the highest and the second highest Expenses (in $) in Malaysia?
Offer a very short reply. 2.58e+09. What is the difference between the highest and the lowest Expenses (in $) of Denmark?
Your answer should be very brief. 1.63e+1. What is the difference between the highest and the lowest Expenses (in $) of Guatemala?
Your answer should be compact. 4.28e+09. What is the difference between the highest and the lowest Expenses (in $) in Honduras?
Make the answer very short. 5.11e+09. What is the difference between the highest and the lowest Expenses (in $) of Malaysia?
Offer a terse response. 1.10e+1. 